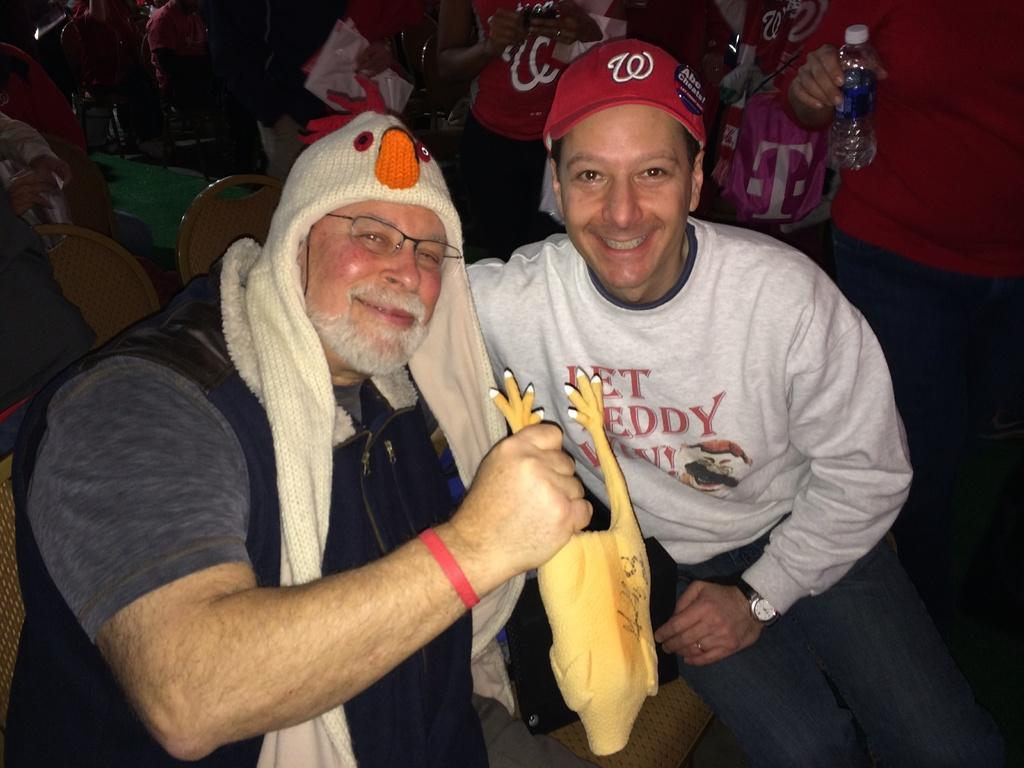<image>
Relay a brief, clear account of the picture shown. A man holding up a chicken poses with another man in a red hat with a button that says Abe Cheats on it. 